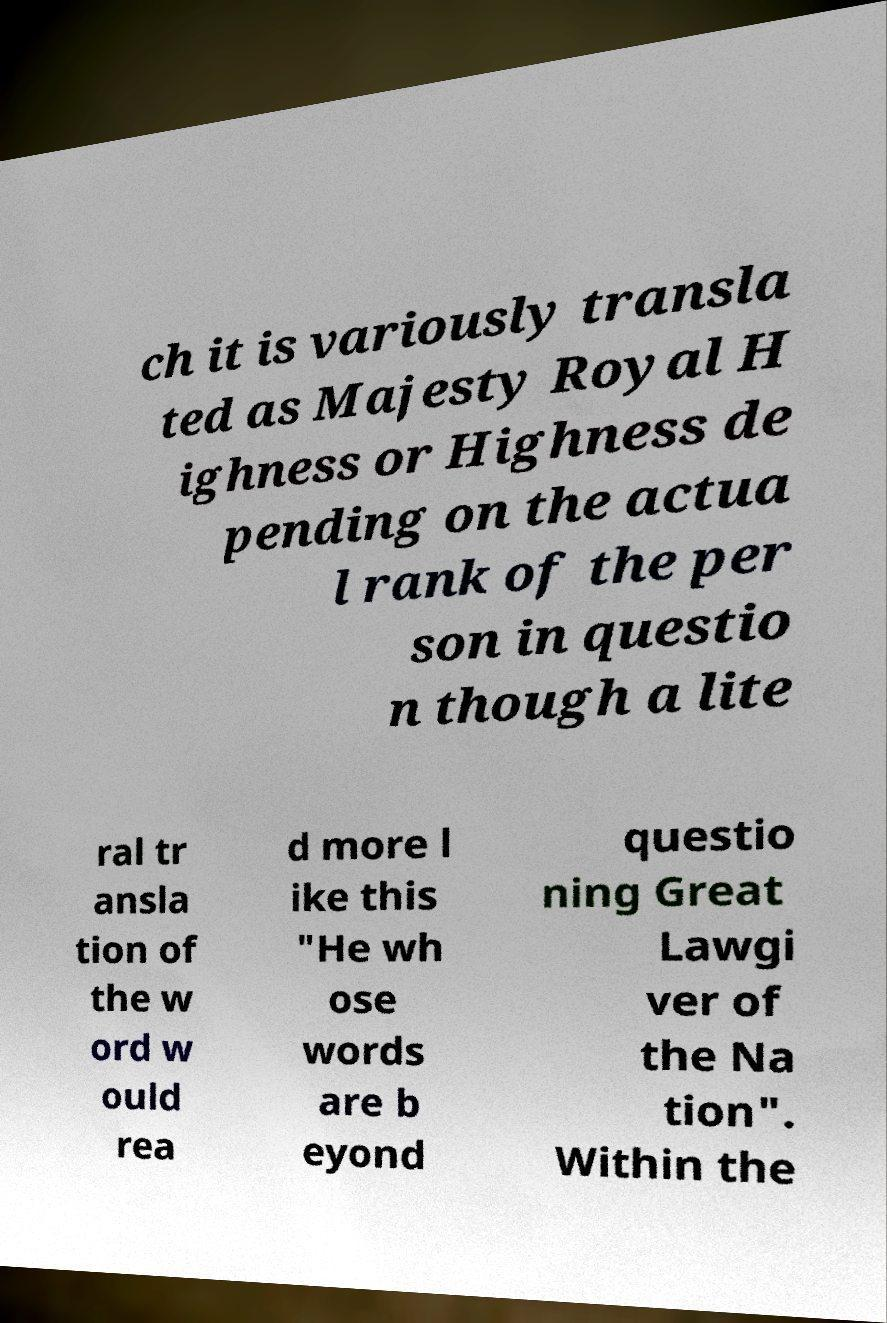What messages or text are displayed in this image? I need them in a readable, typed format. ch it is variously transla ted as Majesty Royal H ighness or Highness de pending on the actua l rank of the per son in questio n though a lite ral tr ansla tion of the w ord w ould rea d more l ike this "He wh ose words are b eyond questio ning Great Lawgi ver of the Na tion". Within the 